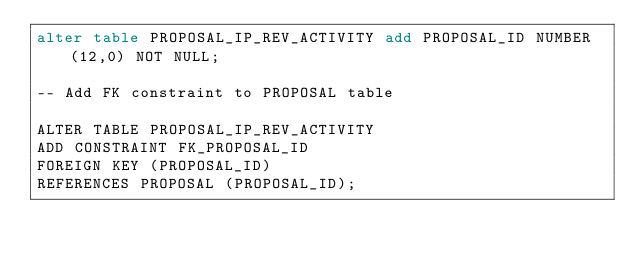<code> <loc_0><loc_0><loc_500><loc_500><_SQL_>alter table PROPOSAL_IP_REV_ACTIVITY add PROPOSAL_ID NUMBER(12,0) NOT NULL; 

-- Add FK constraint to PROPOSAL table 

ALTER TABLE PROPOSAL_IP_REV_ACTIVITY 
ADD CONSTRAINT FK_PROPOSAL_ID 
FOREIGN KEY (PROPOSAL_ID) 
REFERENCES PROPOSAL (PROPOSAL_ID); 
</code> 